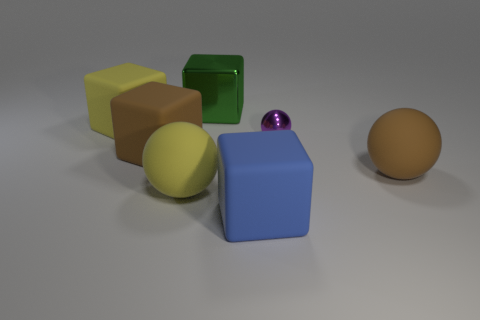There is a yellow object that is right of the big matte cube on the left side of the big brown rubber thing that is on the left side of the small metal ball; how big is it?
Your answer should be very brief. Large. The purple metallic object has what shape?
Give a very brief answer. Sphere. How many spheres are left of the matte cube to the right of the green shiny object?
Keep it short and to the point. 1. What number of other things are there of the same material as the small ball
Keep it short and to the point. 1. Is the small purple sphere right of the blue rubber block made of the same material as the big brown thing that is left of the large green cube?
Provide a succinct answer. No. Is there any other thing that has the same shape as the tiny purple thing?
Offer a terse response. Yes. Does the green cube have the same material as the brown object that is on the right side of the big yellow matte ball?
Ensure brevity in your answer.  No. What is the color of the big matte ball that is to the left of the rubber block in front of the matte ball in front of the large brown rubber sphere?
Provide a succinct answer. Yellow. What shape is the brown thing that is the same size as the brown rubber cube?
Your answer should be very brief. Sphere. Is there any other thing that has the same size as the purple metallic thing?
Keep it short and to the point. No. 